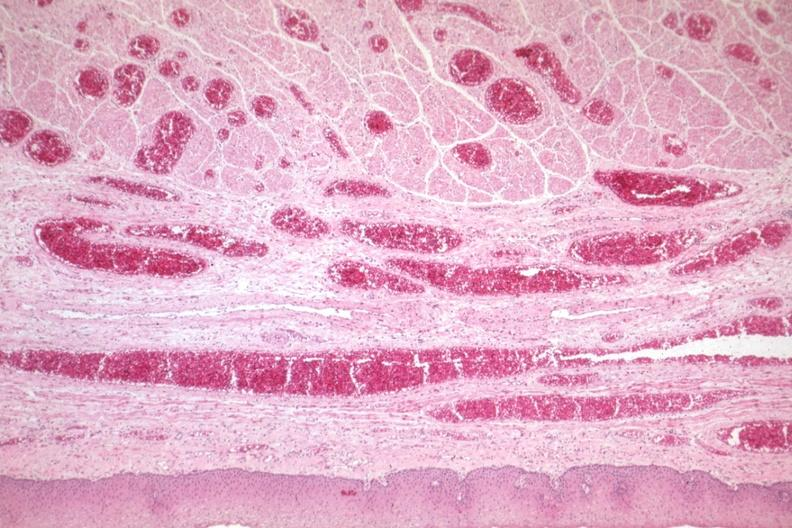s good example of veins filled with blood?
Answer the question using a single word or phrase. Yes 